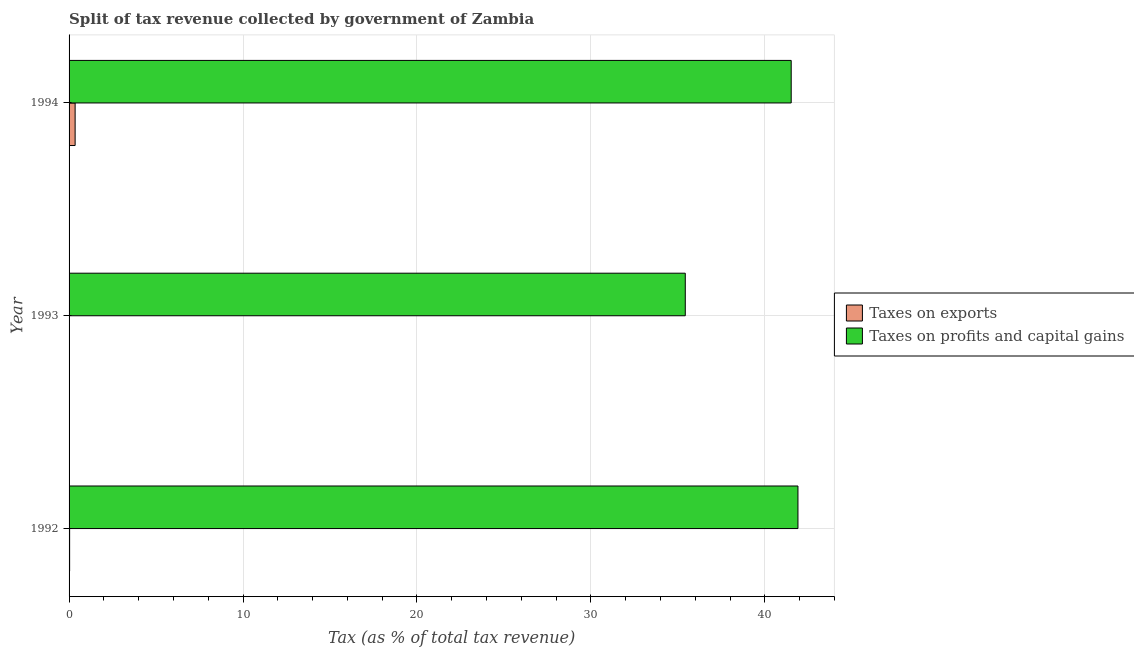How many different coloured bars are there?
Provide a succinct answer. 2. Are the number of bars per tick equal to the number of legend labels?
Keep it short and to the point. Yes. Are the number of bars on each tick of the Y-axis equal?
Provide a succinct answer. Yes. How many bars are there on the 3rd tick from the top?
Ensure brevity in your answer.  2. How many bars are there on the 3rd tick from the bottom?
Provide a succinct answer. 2. What is the label of the 1st group of bars from the top?
Keep it short and to the point. 1994. What is the percentage of revenue obtained from taxes on profits and capital gains in 1993?
Ensure brevity in your answer.  35.43. Across all years, what is the maximum percentage of revenue obtained from taxes on profits and capital gains?
Provide a succinct answer. 41.91. Across all years, what is the minimum percentage of revenue obtained from taxes on profits and capital gains?
Offer a terse response. 35.43. In which year was the percentage of revenue obtained from taxes on exports minimum?
Ensure brevity in your answer.  1993. What is the total percentage of revenue obtained from taxes on exports in the graph?
Your response must be concise. 0.39. What is the difference between the percentage of revenue obtained from taxes on exports in 1993 and that in 1994?
Ensure brevity in your answer.  -0.34. What is the difference between the percentage of revenue obtained from taxes on profits and capital gains in 1992 and the percentage of revenue obtained from taxes on exports in 1994?
Provide a short and direct response. 41.56. What is the average percentage of revenue obtained from taxes on profits and capital gains per year?
Make the answer very short. 39.62. In the year 1994, what is the difference between the percentage of revenue obtained from taxes on profits and capital gains and percentage of revenue obtained from taxes on exports?
Give a very brief answer. 41.17. Is the percentage of revenue obtained from taxes on profits and capital gains in 1992 less than that in 1993?
Ensure brevity in your answer.  No. What is the difference between the highest and the second highest percentage of revenue obtained from taxes on profits and capital gains?
Keep it short and to the point. 0.39. What is the difference between the highest and the lowest percentage of revenue obtained from taxes on exports?
Your response must be concise. 0.34. What does the 2nd bar from the top in 1993 represents?
Ensure brevity in your answer.  Taxes on exports. What does the 1st bar from the bottom in 1993 represents?
Make the answer very short. Taxes on exports. How many bars are there?
Make the answer very short. 6. Are all the bars in the graph horizontal?
Offer a terse response. Yes. How many years are there in the graph?
Make the answer very short. 3. Are the values on the major ticks of X-axis written in scientific E-notation?
Keep it short and to the point. No. Does the graph contain any zero values?
Provide a short and direct response. No. What is the title of the graph?
Give a very brief answer. Split of tax revenue collected by government of Zambia. What is the label or title of the X-axis?
Provide a succinct answer. Tax (as % of total tax revenue). What is the label or title of the Y-axis?
Your answer should be compact. Year. What is the Tax (as % of total tax revenue) of Taxes on exports in 1992?
Ensure brevity in your answer.  0.03. What is the Tax (as % of total tax revenue) of Taxes on profits and capital gains in 1992?
Provide a short and direct response. 41.91. What is the Tax (as % of total tax revenue) in Taxes on exports in 1993?
Give a very brief answer. 0.01. What is the Tax (as % of total tax revenue) in Taxes on profits and capital gains in 1993?
Offer a very short reply. 35.43. What is the Tax (as % of total tax revenue) in Taxes on exports in 1994?
Your answer should be compact. 0.35. What is the Tax (as % of total tax revenue) of Taxes on profits and capital gains in 1994?
Your response must be concise. 41.52. Across all years, what is the maximum Tax (as % of total tax revenue) of Taxes on exports?
Your response must be concise. 0.35. Across all years, what is the maximum Tax (as % of total tax revenue) in Taxes on profits and capital gains?
Offer a very short reply. 41.91. Across all years, what is the minimum Tax (as % of total tax revenue) in Taxes on exports?
Your response must be concise. 0.01. Across all years, what is the minimum Tax (as % of total tax revenue) of Taxes on profits and capital gains?
Your response must be concise. 35.43. What is the total Tax (as % of total tax revenue) of Taxes on exports in the graph?
Offer a very short reply. 0.39. What is the total Tax (as % of total tax revenue) of Taxes on profits and capital gains in the graph?
Make the answer very short. 118.85. What is the difference between the Tax (as % of total tax revenue) of Taxes on exports in 1992 and that in 1993?
Give a very brief answer. 0.03. What is the difference between the Tax (as % of total tax revenue) in Taxes on profits and capital gains in 1992 and that in 1993?
Offer a very short reply. 6.48. What is the difference between the Tax (as % of total tax revenue) of Taxes on exports in 1992 and that in 1994?
Ensure brevity in your answer.  -0.32. What is the difference between the Tax (as % of total tax revenue) in Taxes on profits and capital gains in 1992 and that in 1994?
Offer a very short reply. 0.39. What is the difference between the Tax (as % of total tax revenue) in Taxes on exports in 1993 and that in 1994?
Provide a succinct answer. -0.34. What is the difference between the Tax (as % of total tax revenue) in Taxes on profits and capital gains in 1993 and that in 1994?
Provide a succinct answer. -6.09. What is the difference between the Tax (as % of total tax revenue) of Taxes on exports in 1992 and the Tax (as % of total tax revenue) of Taxes on profits and capital gains in 1993?
Your response must be concise. -35.4. What is the difference between the Tax (as % of total tax revenue) of Taxes on exports in 1992 and the Tax (as % of total tax revenue) of Taxes on profits and capital gains in 1994?
Give a very brief answer. -41.49. What is the difference between the Tax (as % of total tax revenue) in Taxes on exports in 1993 and the Tax (as % of total tax revenue) in Taxes on profits and capital gains in 1994?
Your response must be concise. -41.51. What is the average Tax (as % of total tax revenue) of Taxes on exports per year?
Offer a very short reply. 0.13. What is the average Tax (as % of total tax revenue) in Taxes on profits and capital gains per year?
Make the answer very short. 39.62. In the year 1992, what is the difference between the Tax (as % of total tax revenue) in Taxes on exports and Tax (as % of total tax revenue) in Taxes on profits and capital gains?
Provide a short and direct response. -41.87. In the year 1993, what is the difference between the Tax (as % of total tax revenue) in Taxes on exports and Tax (as % of total tax revenue) in Taxes on profits and capital gains?
Your response must be concise. -35.42. In the year 1994, what is the difference between the Tax (as % of total tax revenue) in Taxes on exports and Tax (as % of total tax revenue) in Taxes on profits and capital gains?
Ensure brevity in your answer.  -41.17. What is the ratio of the Tax (as % of total tax revenue) in Taxes on exports in 1992 to that in 1993?
Ensure brevity in your answer.  5.98. What is the ratio of the Tax (as % of total tax revenue) of Taxes on profits and capital gains in 1992 to that in 1993?
Ensure brevity in your answer.  1.18. What is the ratio of the Tax (as % of total tax revenue) of Taxes on exports in 1992 to that in 1994?
Offer a very short reply. 0.09. What is the ratio of the Tax (as % of total tax revenue) of Taxes on profits and capital gains in 1992 to that in 1994?
Offer a very short reply. 1.01. What is the ratio of the Tax (as % of total tax revenue) in Taxes on exports in 1993 to that in 1994?
Offer a very short reply. 0.02. What is the ratio of the Tax (as % of total tax revenue) in Taxes on profits and capital gains in 1993 to that in 1994?
Provide a succinct answer. 0.85. What is the difference between the highest and the second highest Tax (as % of total tax revenue) of Taxes on exports?
Provide a succinct answer. 0.32. What is the difference between the highest and the second highest Tax (as % of total tax revenue) of Taxes on profits and capital gains?
Your response must be concise. 0.39. What is the difference between the highest and the lowest Tax (as % of total tax revenue) of Taxes on exports?
Offer a terse response. 0.34. What is the difference between the highest and the lowest Tax (as % of total tax revenue) of Taxes on profits and capital gains?
Your response must be concise. 6.48. 